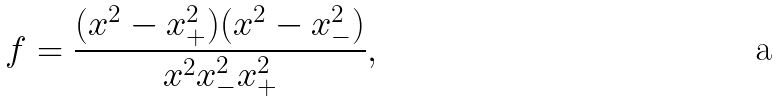Convert formula to latex. <formula><loc_0><loc_0><loc_500><loc_500>f = \frac { ( x ^ { 2 } - x _ { + } ^ { 2 } ) ( x ^ { 2 } - x _ { - } ^ { 2 } ) } { x ^ { 2 } x _ { - } ^ { 2 } x _ { + } ^ { 2 } } ,</formula> 